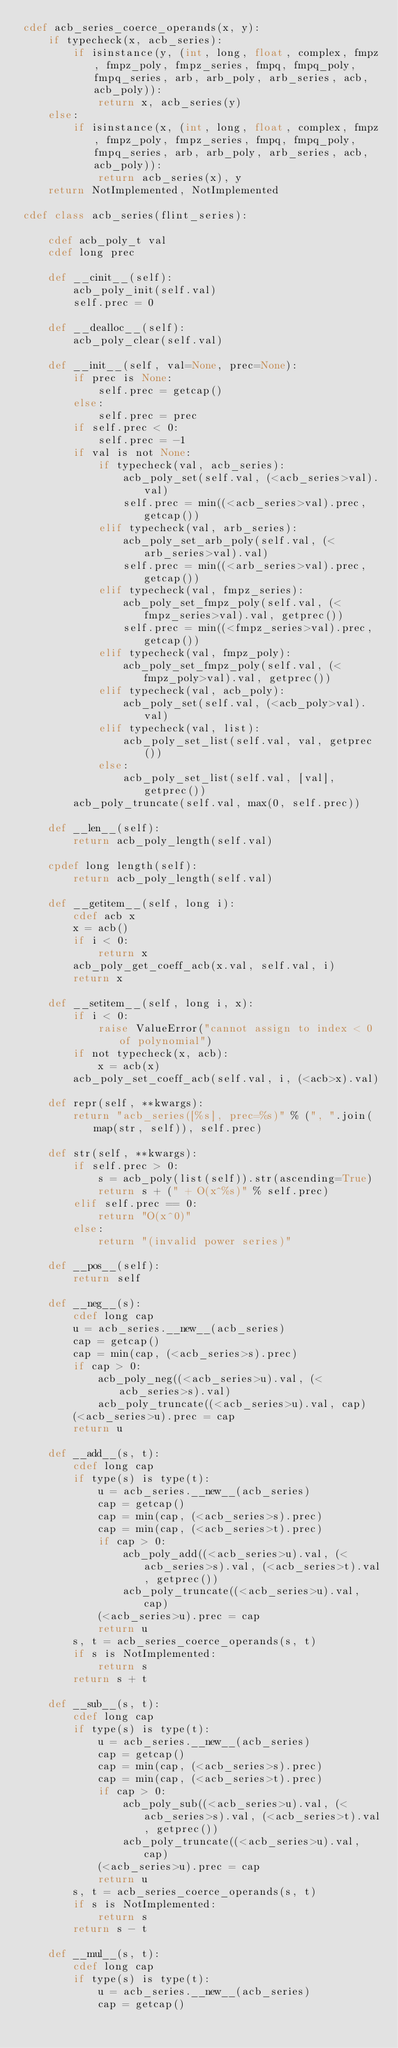Convert code to text. <code><loc_0><loc_0><loc_500><loc_500><_Cython_>cdef acb_series_coerce_operands(x, y):
    if typecheck(x, acb_series):
        if isinstance(y, (int, long, float, complex, fmpz, fmpz_poly, fmpz_series, fmpq, fmpq_poly, fmpq_series, arb, arb_poly, arb_series, acb, acb_poly)):
            return x, acb_series(y)
    else:
        if isinstance(x, (int, long, float, complex, fmpz, fmpz_poly, fmpz_series, fmpq, fmpq_poly, fmpq_series, arb, arb_poly, arb_series, acb, acb_poly)):
            return acb_series(x), y
    return NotImplemented, NotImplemented

cdef class acb_series(flint_series):

    cdef acb_poly_t val
    cdef long prec

    def __cinit__(self):
        acb_poly_init(self.val)
        self.prec = 0

    def __dealloc__(self):
        acb_poly_clear(self.val)

    def __init__(self, val=None, prec=None):
        if prec is None:
            self.prec = getcap()
        else:
            self.prec = prec
        if self.prec < 0:
            self.prec = -1
        if val is not None:
            if typecheck(val, acb_series):
                acb_poly_set(self.val, (<acb_series>val).val)
                self.prec = min((<acb_series>val).prec, getcap())
            elif typecheck(val, arb_series):
                acb_poly_set_arb_poly(self.val, (<arb_series>val).val)
                self.prec = min((<arb_series>val).prec, getcap())
            elif typecheck(val, fmpz_series):
                acb_poly_set_fmpz_poly(self.val, (<fmpz_series>val).val, getprec())
                self.prec = min((<fmpz_series>val).prec, getcap())
            elif typecheck(val, fmpz_poly):
                acb_poly_set_fmpz_poly(self.val, (<fmpz_poly>val).val, getprec())
            elif typecheck(val, acb_poly):
                acb_poly_set(self.val, (<acb_poly>val).val)
            elif typecheck(val, list):
                acb_poly_set_list(self.val, val, getprec())
            else:
                acb_poly_set_list(self.val, [val], getprec())
        acb_poly_truncate(self.val, max(0, self.prec))

    def __len__(self):
        return acb_poly_length(self.val)

    cpdef long length(self):
        return acb_poly_length(self.val)

    def __getitem__(self, long i):
        cdef acb x
        x = acb()
        if i < 0:
            return x
        acb_poly_get_coeff_acb(x.val, self.val, i)
        return x

    def __setitem__(self, long i, x):
        if i < 0:
            raise ValueError("cannot assign to index < 0 of polynomial")
        if not typecheck(x, acb):
            x = acb(x)
        acb_poly_set_coeff_acb(self.val, i, (<acb>x).val)

    def repr(self, **kwargs):
        return "acb_series([%s], prec=%s)" % (", ".join(map(str, self)), self.prec)

    def str(self, **kwargs):
        if self.prec > 0:
            s = acb_poly(list(self)).str(ascending=True)
            return s + (" + O(x^%s)" % self.prec)
        elif self.prec == 0:
            return "O(x^0)"
        else:
            return "(invalid power series)"

    def __pos__(self):
        return self

    def __neg__(s):
        cdef long cap
        u = acb_series.__new__(acb_series)
        cap = getcap()
        cap = min(cap, (<acb_series>s).prec)
        if cap > 0:
            acb_poly_neg((<acb_series>u).val, (<acb_series>s).val)
            acb_poly_truncate((<acb_series>u).val, cap)
        (<acb_series>u).prec = cap
        return u

    def __add__(s, t):
        cdef long cap
        if type(s) is type(t):
            u = acb_series.__new__(acb_series)
            cap = getcap()
            cap = min(cap, (<acb_series>s).prec)
            cap = min(cap, (<acb_series>t).prec)
            if cap > 0:
                acb_poly_add((<acb_series>u).val, (<acb_series>s).val, (<acb_series>t).val, getprec())
                acb_poly_truncate((<acb_series>u).val, cap)
            (<acb_series>u).prec = cap
            return u
        s, t = acb_series_coerce_operands(s, t)
        if s is NotImplemented:
            return s
        return s + t

    def __sub__(s, t):
        cdef long cap
        if type(s) is type(t):
            u = acb_series.__new__(acb_series)
            cap = getcap()
            cap = min(cap, (<acb_series>s).prec)
            cap = min(cap, (<acb_series>t).prec)
            if cap > 0:
                acb_poly_sub((<acb_series>u).val, (<acb_series>s).val, (<acb_series>t).val, getprec())
                acb_poly_truncate((<acb_series>u).val, cap)
            (<acb_series>u).prec = cap
            return u
        s, t = acb_series_coerce_operands(s, t)
        if s is NotImplemented:
            return s
        return s - t

    def __mul__(s, t):
        cdef long cap
        if type(s) is type(t):
            u = acb_series.__new__(acb_series)
            cap = getcap()</code> 